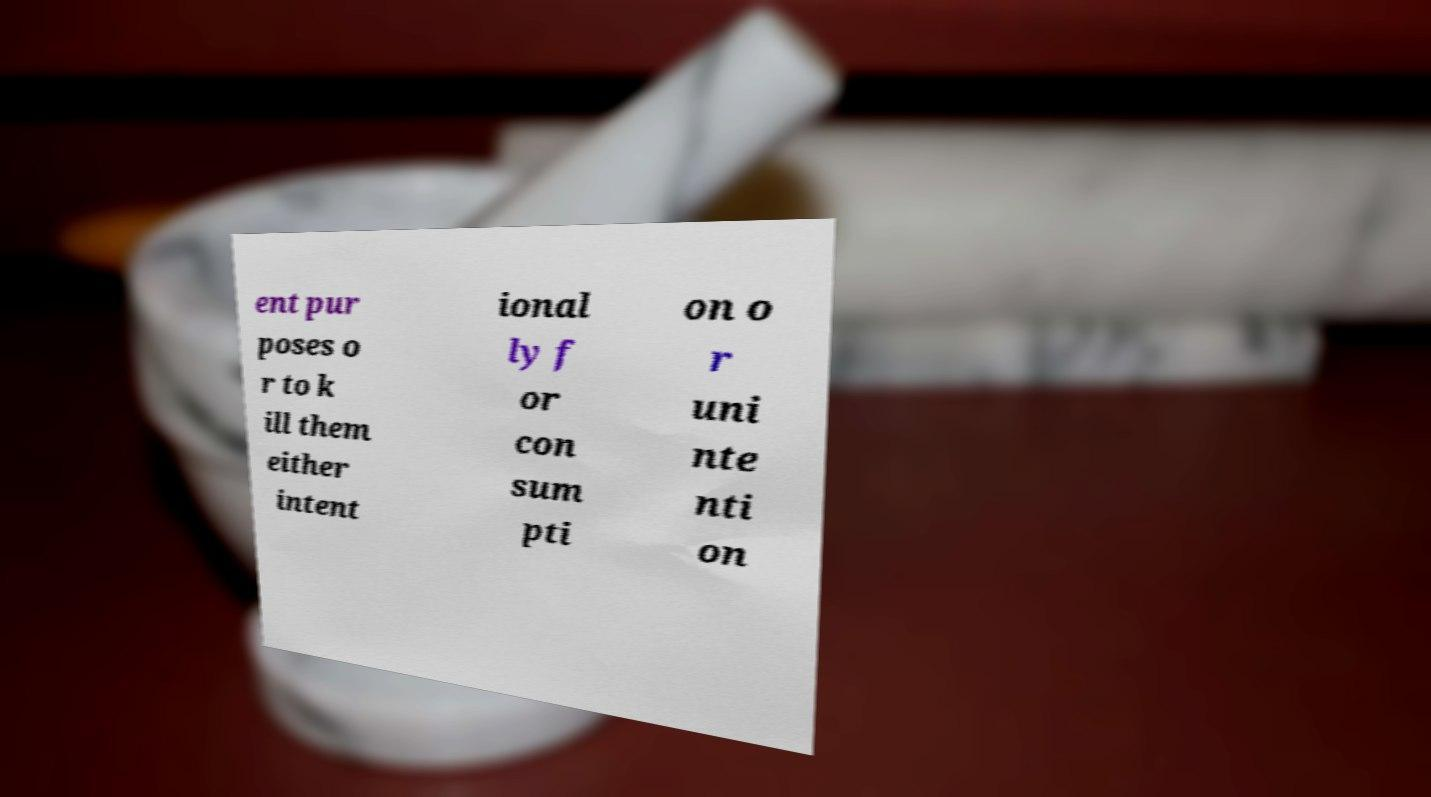What messages or text are displayed in this image? I need them in a readable, typed format. ent pur poses o r to k ill them either intent ional ly f or con sum pti on o r uni nte nti on 